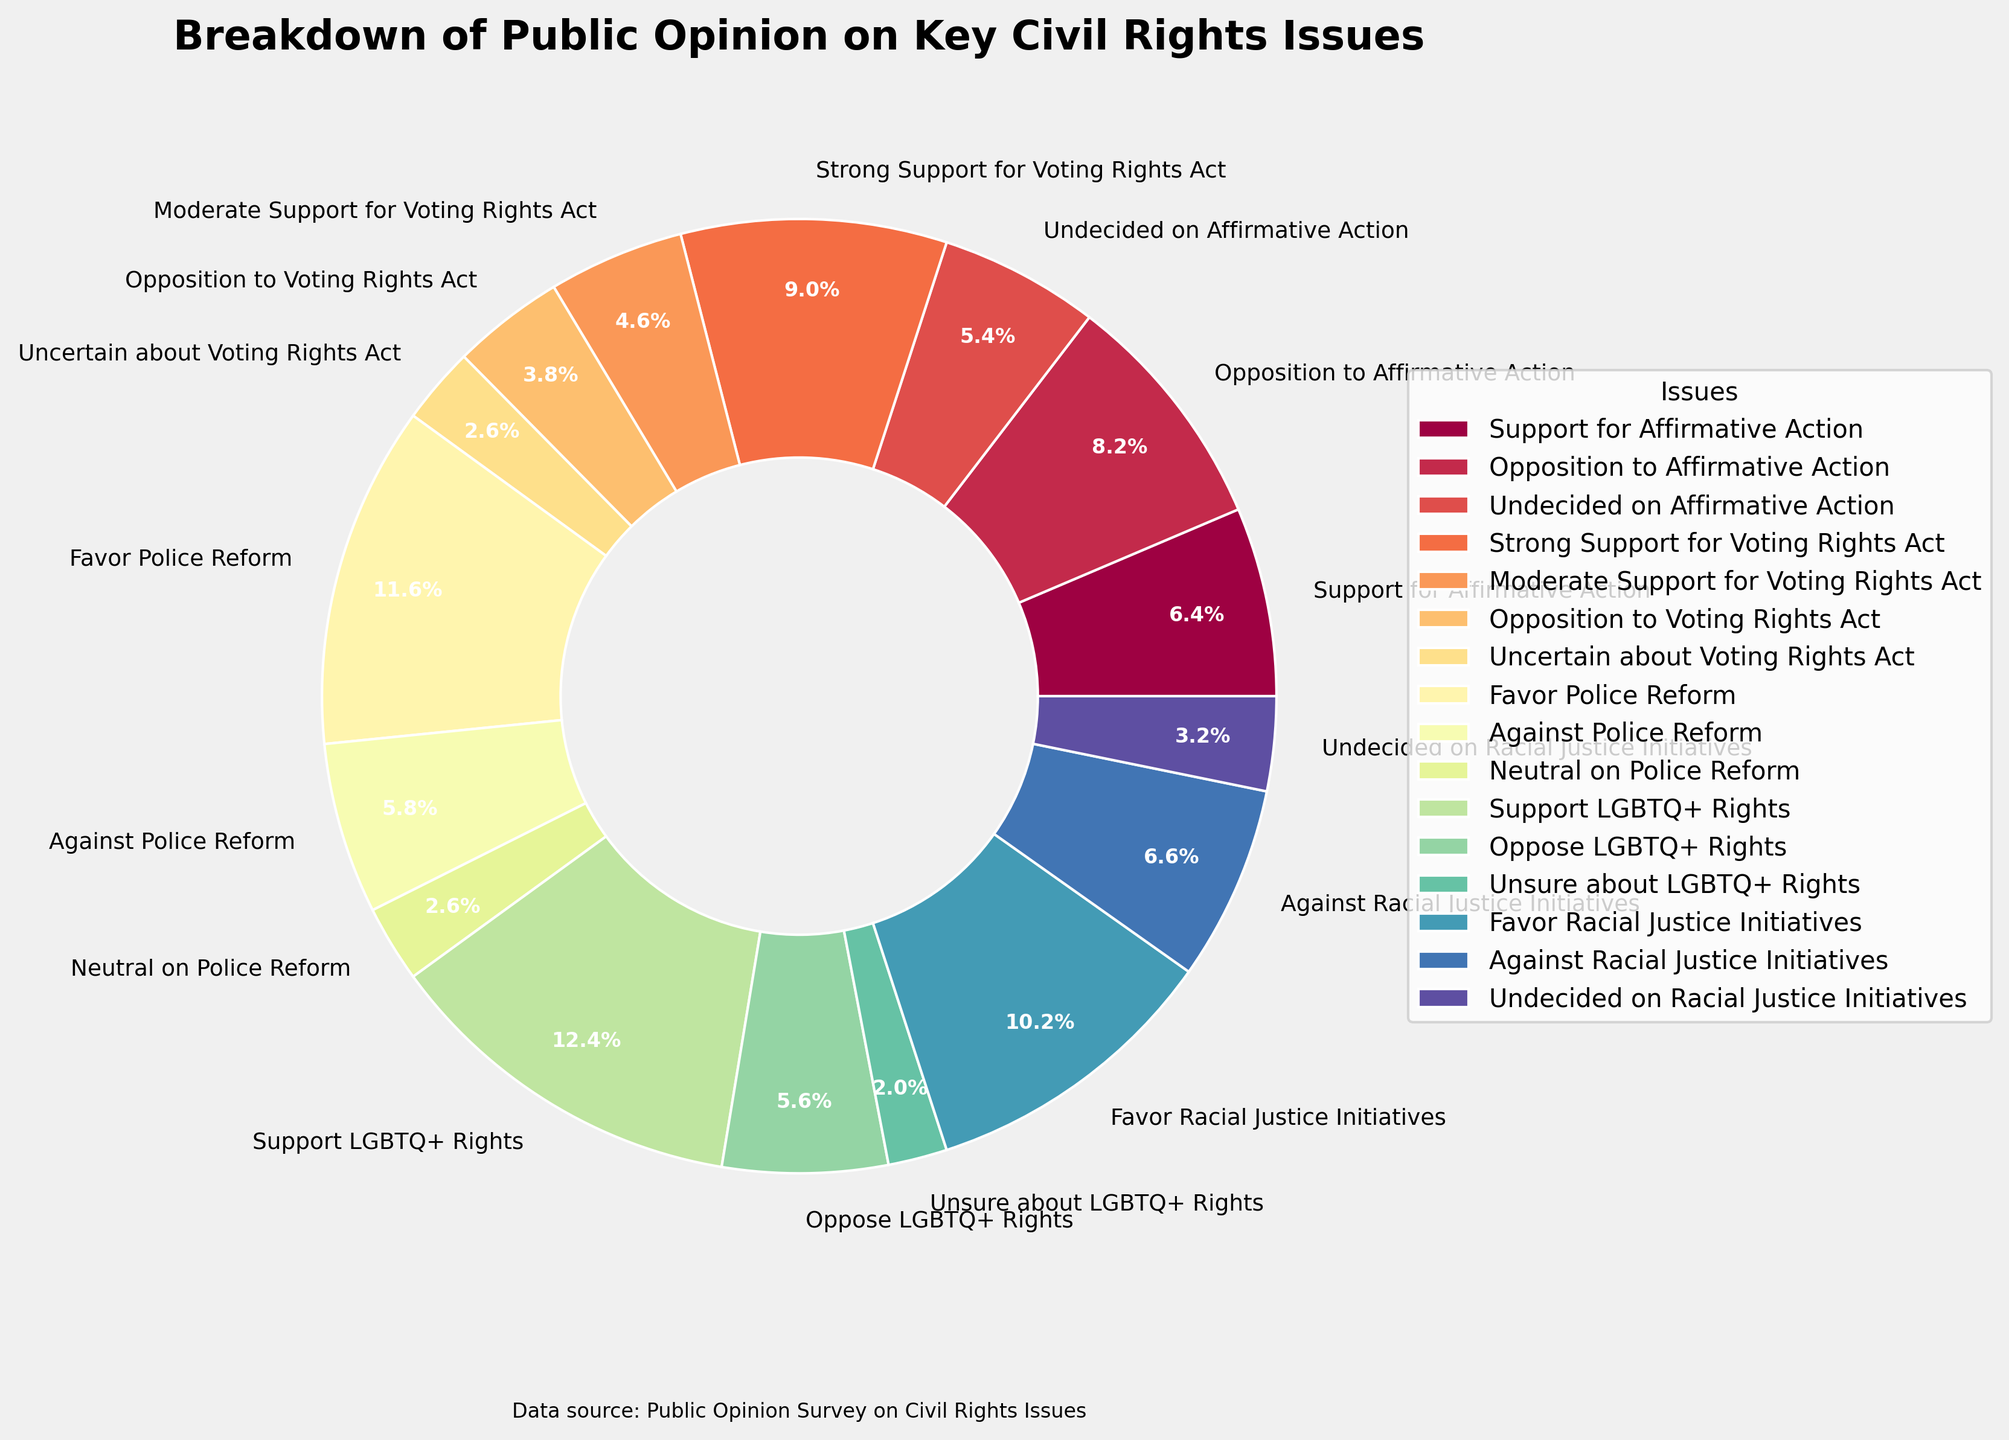What is the percentage of people who support or oppose Affirmative Action? Adding the percentage of those who support Affirmative Action (32%) and those who oppose it (41%) gives 32% + 41% = 73%
Answer: 73% Which issue has the highest level of support, and what is that percentage? From the chart, Support LGBTQ+ Rights has the highest level of support at 62%
Answer: Support LGBTQ+ Rights, 62% How many people are undecided or uncertain about the Voting Rights Act? Adding the percentages of those who are uncertain (13%) and undecided (0% as "undecided" isn't listed but assumed similarly) about the Voting Rights Act gives 13%
Answer: 13% What is the majority view on Police Reform, and by what margin? Favor Police Reform is 58% and Against Police Reform is 29%. The margin is 58% - 29% = 29%
Answer: Favor Police Reform, 29% Does support for Racial Justice Initiatives exceed opposition plus undecided? The support for Racial Justice Initiatives is 51%. Opposition is 33% and undecided is 16%. Opposition plus undecided is 33% + 16% = 49%. 51% > 49%
Answer: Yes Which civil rights issue has the most divided opinion based on the given data? Affirmative Action has a split between support (32%), opposition (41%), and undecided (27%), indicating a highly divided opinion compared to other issues
Answer: Affirmative Action What percentage of people favor LGBTQ+ rights and racial justice initiatives combined? Adding support for LGBTQ+ rights (62%) and support for racial justice initiatives (51%) gives 62% + 51% = 113%
Answer: 113% What is the percentage difference between support and opposition for the Voting Rights Act? Strong support (45%) plus moderate support (23%) is 68%. Opposition is 19%. The difference is 68% - 19% = 49%
Answer: 49% Which issue has the lowest percentage of undecided or neutral responses, and what is that percentage? Undecided on Affirmative Action is 27%, Uncertain about Voting Rights Act is 13%, Neutral on Police Reform is 13%, and Unsure about LGBTQ+ rights is 10%, Undecided on Racial Justice Initiatives is 16%. The lowest is Unsure about LGBTQ+ rights at 10%
Answer: LGBTQ+ Rights, 10% What is the combined percentage of people who either oppose Affirmative Action or are against Racial Justice Initiatives? Adding opposition to Affirmative Action (41%) and against racial justice initiatives (33%) gives 41% + 33% = 74%
Answer: 74% 